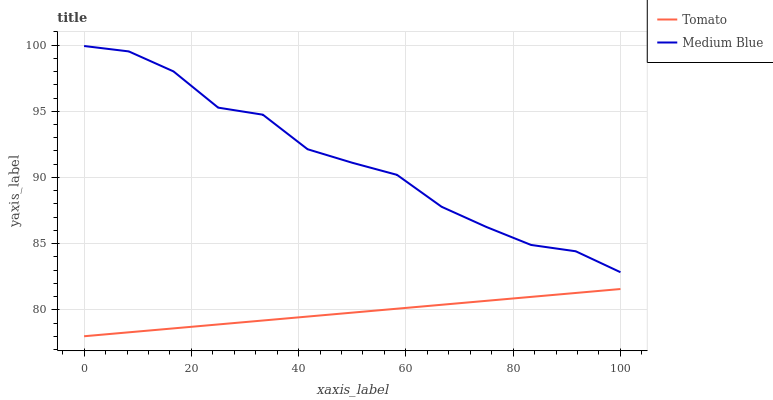Does Tomato have the minimum area under the curve?
Answer yes or no. Yes. Does Medium Blue have the maximum area under the curve?
Answer yes or no. Yes. Does Medium Blue have the minimum area under the curve?
Answer yes or no. No. Is Tomato the smoothest?
Answer yes or no. Yes. Is Medium Blue the roughest?
Answer yes or no. Yes. Is Medium Blue the smoothest?
Answer yes or no. No. Does Tomato have the lowest value?
Answer yes or no. Yes. Does Medium Blue have the lowest value?
Answer yes or no. No. Does Medium Blue have the highest value?
Answer yes or no. Yes. Is Tomato less than Medium Blue?
Answer yes or no. Yes. Is Medium Blue greater than Tomato?
Answer yes or no. Yes. Does Tomato intersect Medium Blue?
Answer yes or no. No. 